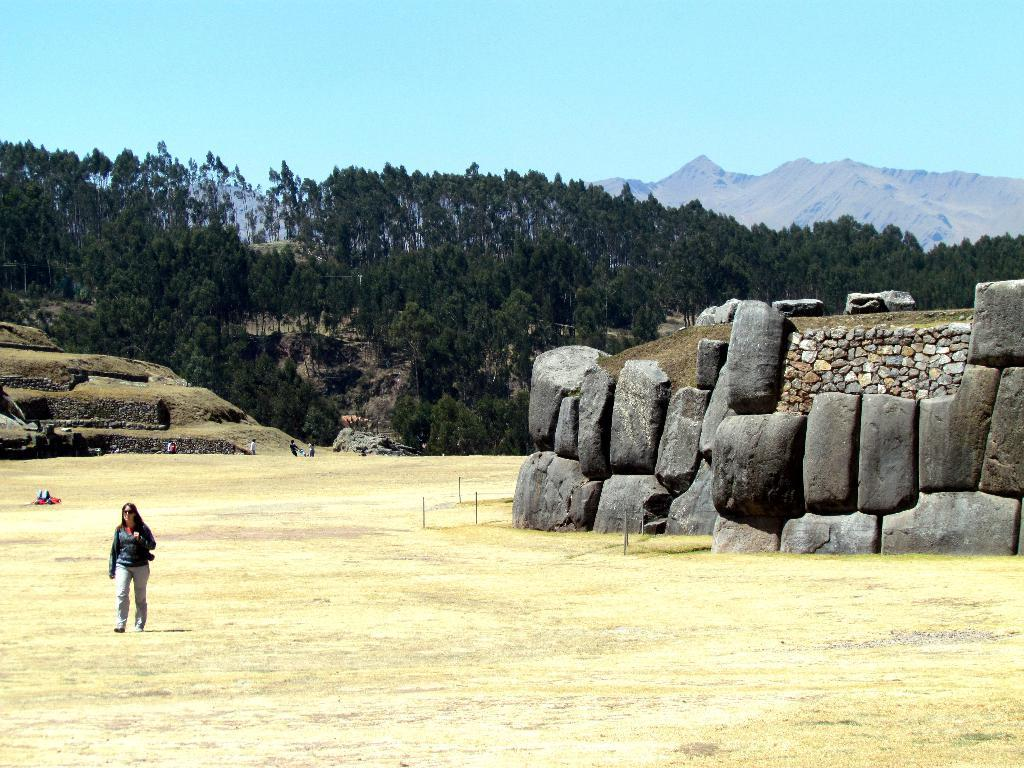What is the person in the image doing? The person is walking on grass. What type of terrain can be seen in the image? Stones are visible in the image. What can be seen in the background of the image? There are people, trees, hills, and the sky visible in the background of the image. What type of alarm is ringing in the image? There is no alarm present in the image. Can you tell me how many sheep are grazing on the hills in the image? There are no sheep visible in the image; only trees and hills can be seen in the background. 